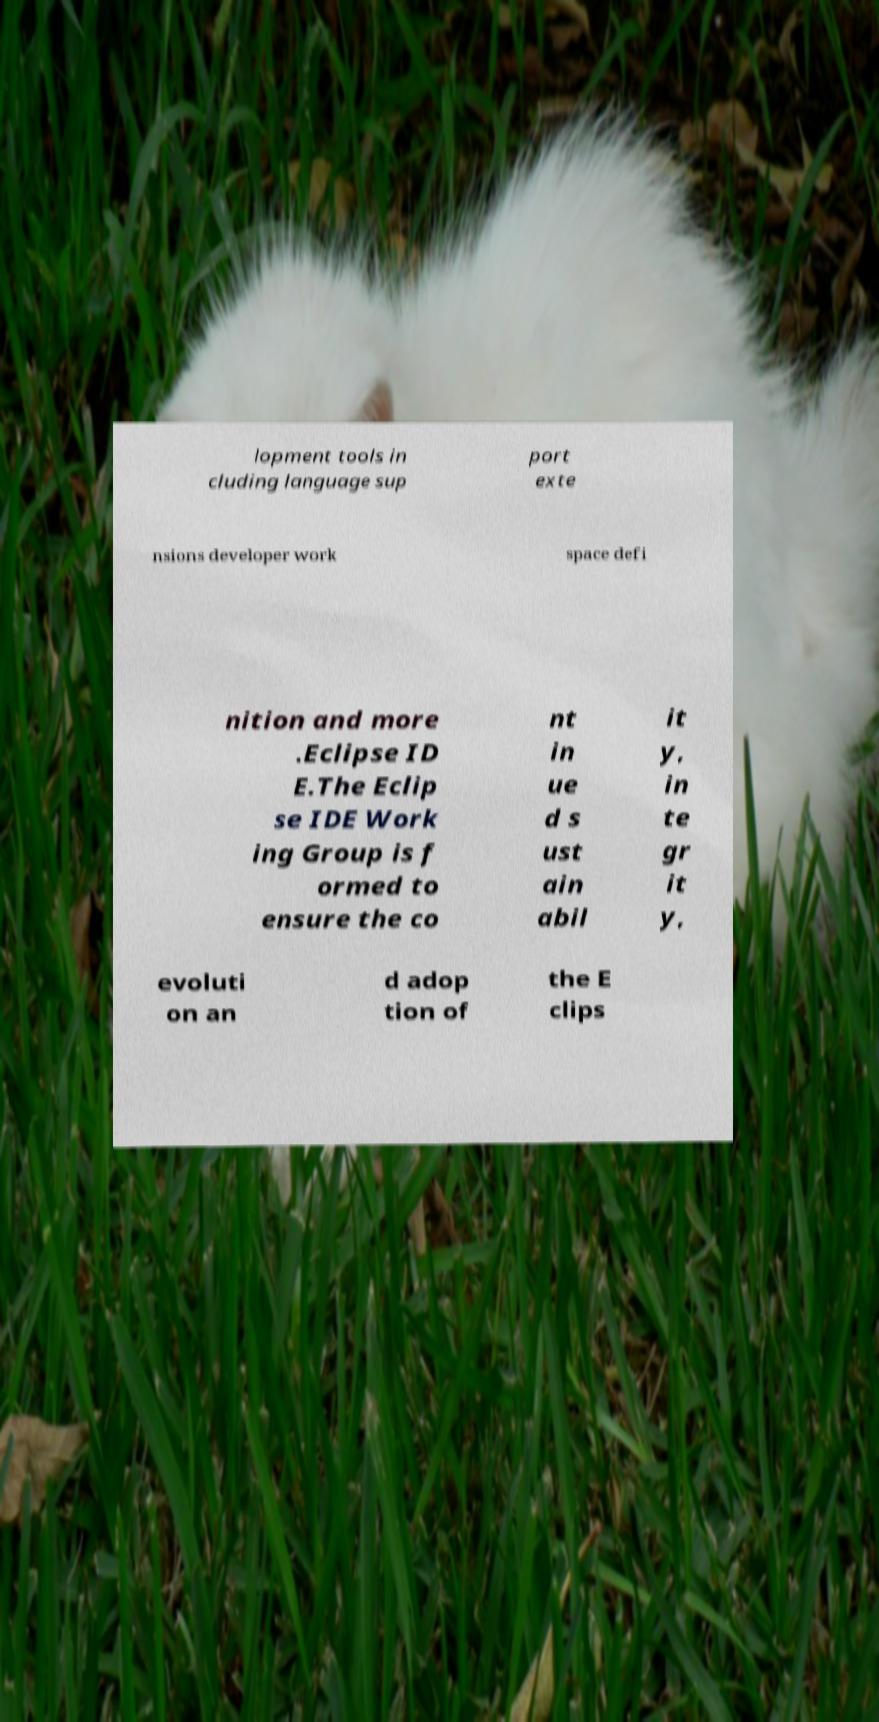Please read and relay the text visible in this image. What does it say? lopment tools in cluding language sup port exte nsions developer work space defi nition and more .Eclipse ID E.The Eclip se IDE Work ing Group is f ormed to ensure the co nt in ue d s ust ain abil it y, in te gr it y, evoluti on an d adop tion of the E clips 